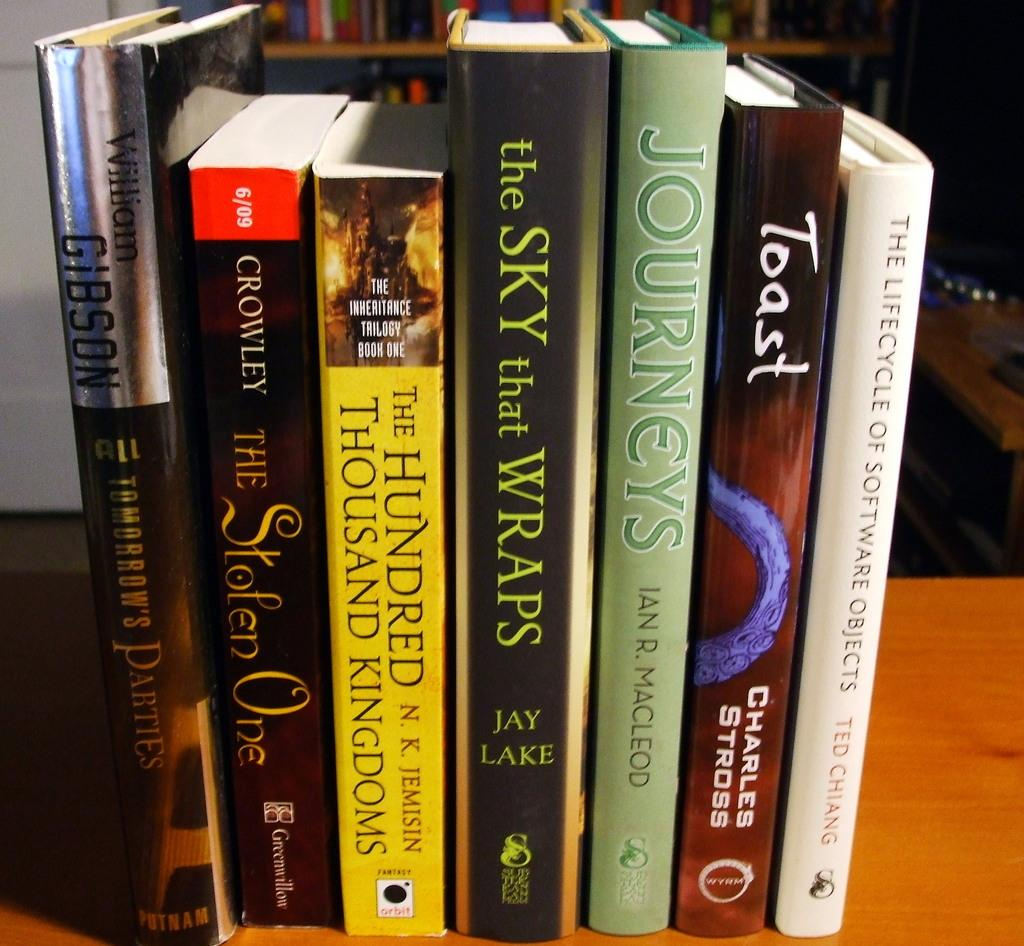<image>
Write a terse but informative summary of the picture. A book called Toast by Charles Stross is next to a book by Ted Chiang 